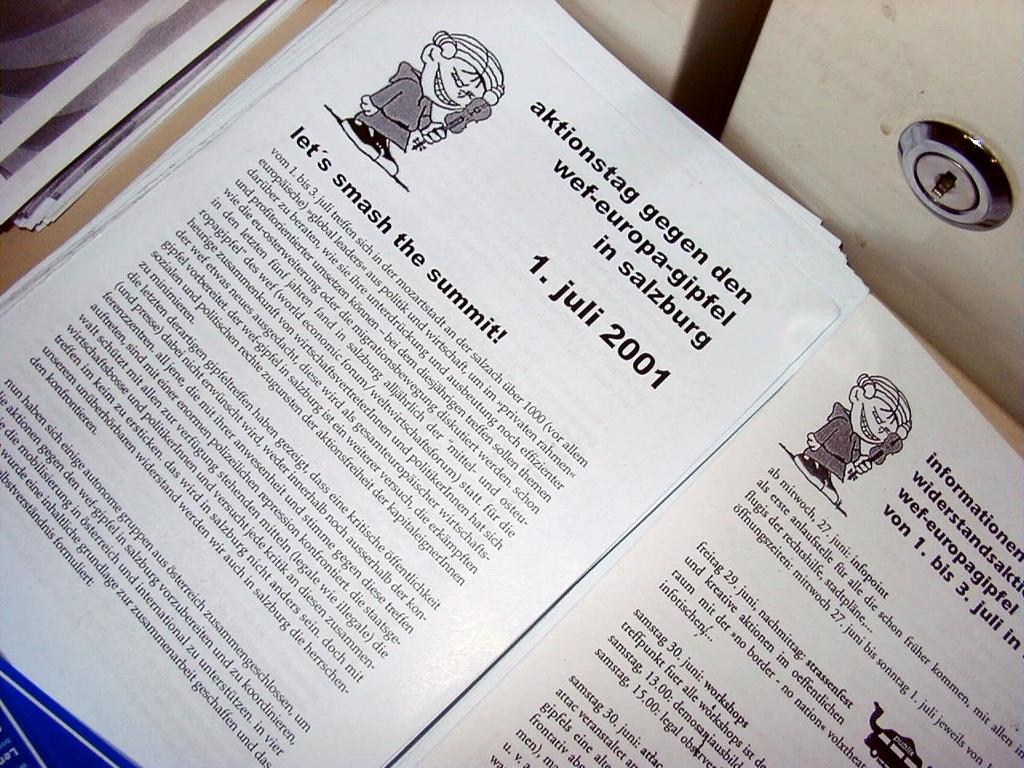Provide a one-sentence caption for the provided image. a paper that says 'smash the summit!' on it. 